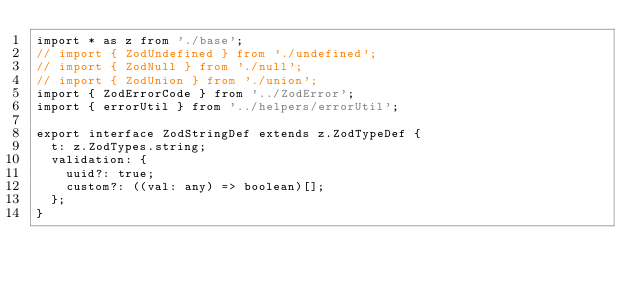Convert code to text. <code><loc_0><loc_0><loc_500><loc_500><_TypeScript_>import * as z from './base';
// import { ZodUndefined } from './undefined';
// import { ZodNull } from './null';
// import { ZodUnion } from './union';
import { ZodErrorCode } from '../ZodError';
import { errorUtil } from '../helpers/errorUtil';

export interface ZodStringDef extends z.ZodTypeDef {
  t: z.ZodTypes.string;
  validation: {
    uuid?: true;
    custom?: ((val: any) => boolean)[];
  };
}
</code> 